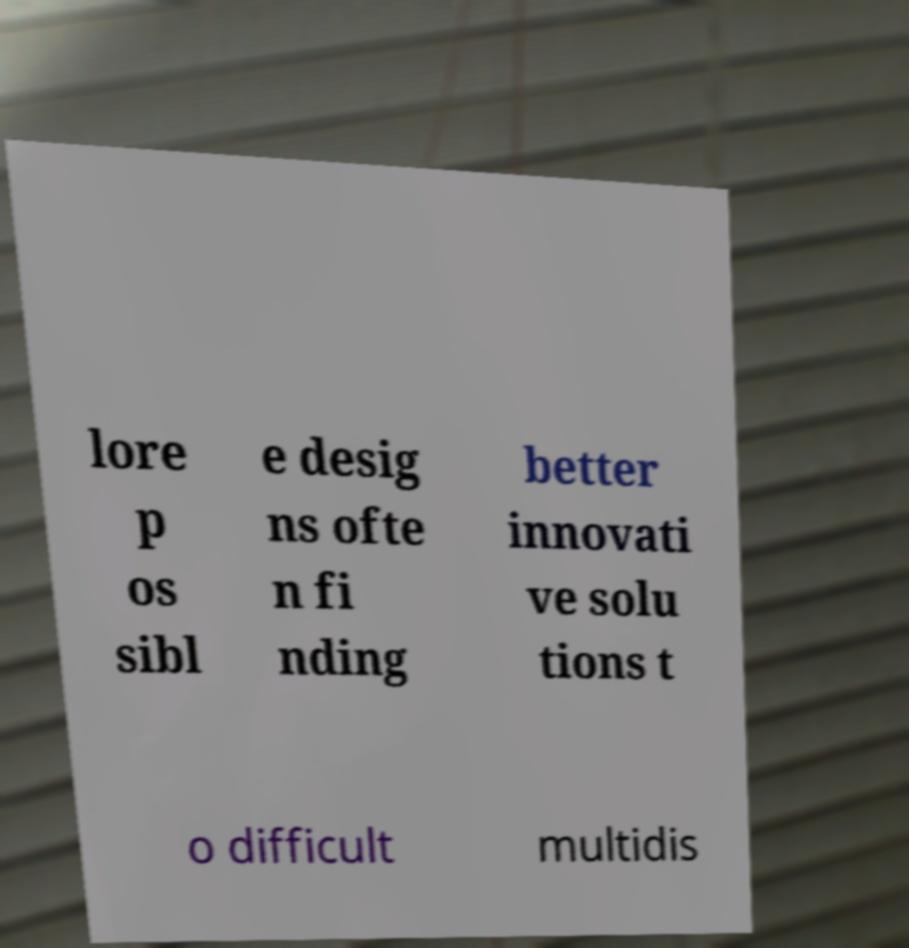Could you assist in decoding the text presented in this image and type it out clearly? lore p os sibl e desig ns ofte n fi nding better innovati ve solu tions t o difficult multidis 